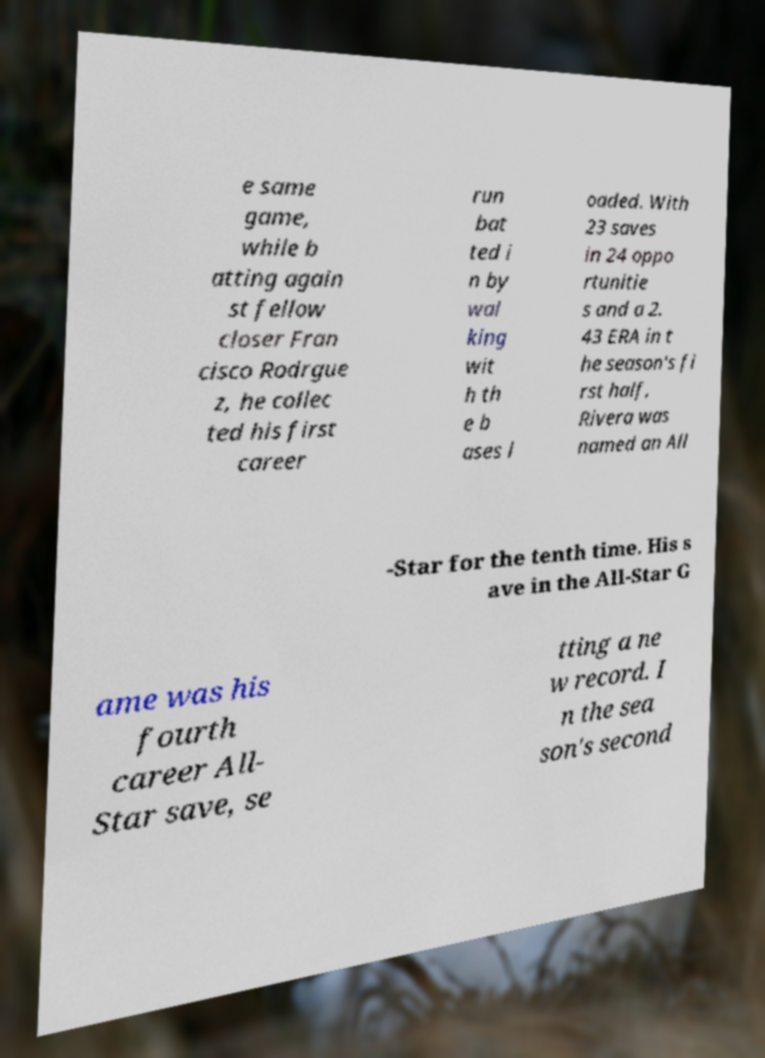Can you read and provide the text displayed in the image?This photo seems to have some interesting text. Can you extract and type it out for me? e same game, while b atting again st fellow closer Fran cisco Rodrgue z, he collec ted his first career run bat ted i n by wal king wit h th e b ases l oaded. With 23 saves in 24 oppo rtunitie s and a 2. 43 ERA in t he season's fi rst half, Rivera was named an All -Star for the tenth time. His s ave in the All-Star G ame was his fourth career All- Star save, se tting a ne w record. I n the sea son's second 